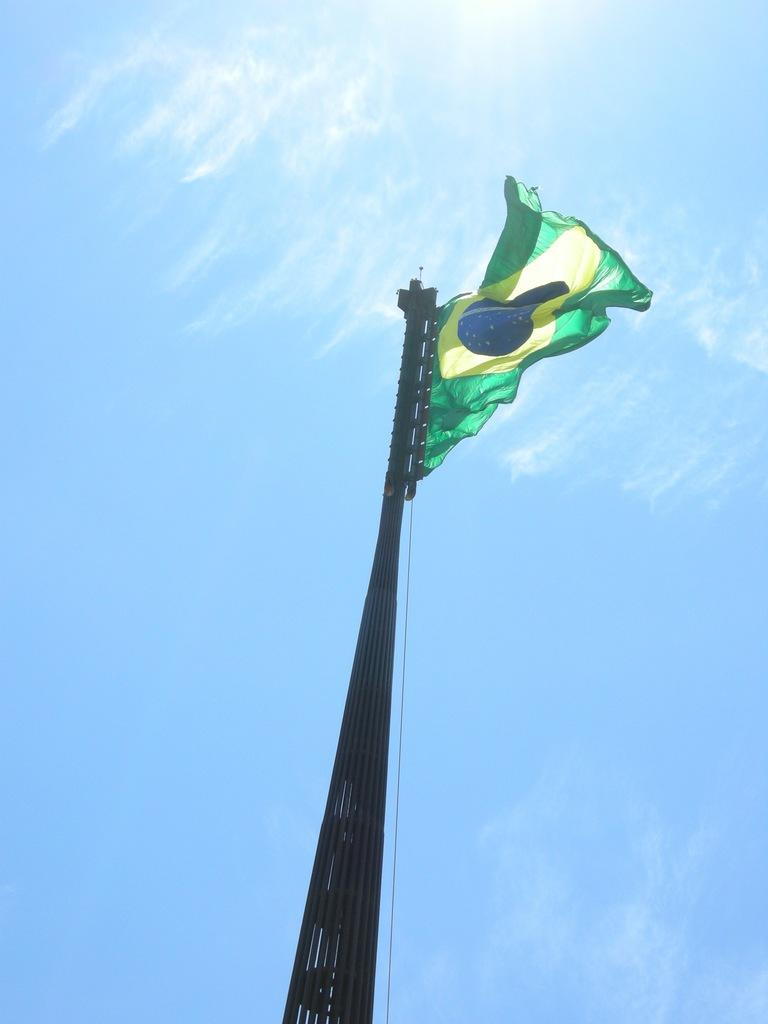What is present in the image that represents a country or organization? There is a flag in the image. How is the flag supported or displayed in the image? The flag is attached to a pole. What color is the sky in the image? The sky is pale blue in the image. Where is the bat hanging in the image? There is no bat present in the image. What type of food is being served in the lunchroom in the image? There is no lunchroom present in the image. 